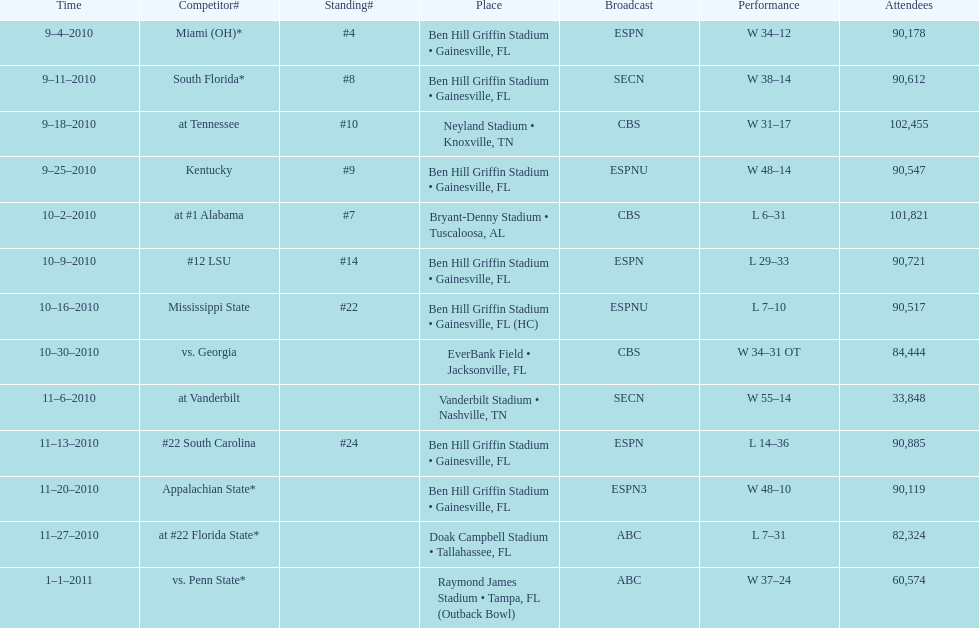What was the difference between the two scores of the last game? 13 points. 